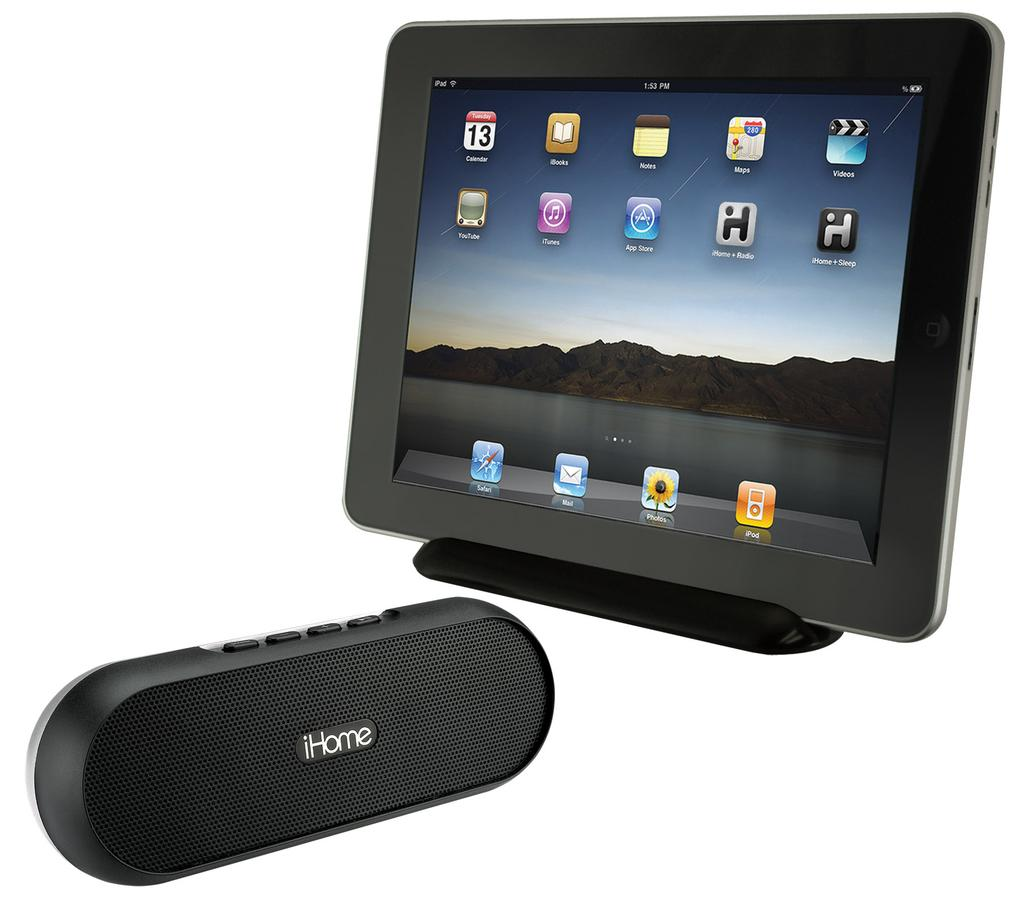What type of speaker is in the image? There is a black Ihome speaker in the image. How is the Ihome speaker positioned in the image? The Ihome speaker is placed on a stand. What other electronic device is in the image? There is a tablet in the image. How is the tablet positioned in the image? The tablet is kept in a stand. What type of cake is on the grass in the image? There is no cake or grass present in the image; it only features an Ihome speaker and a tablet. 